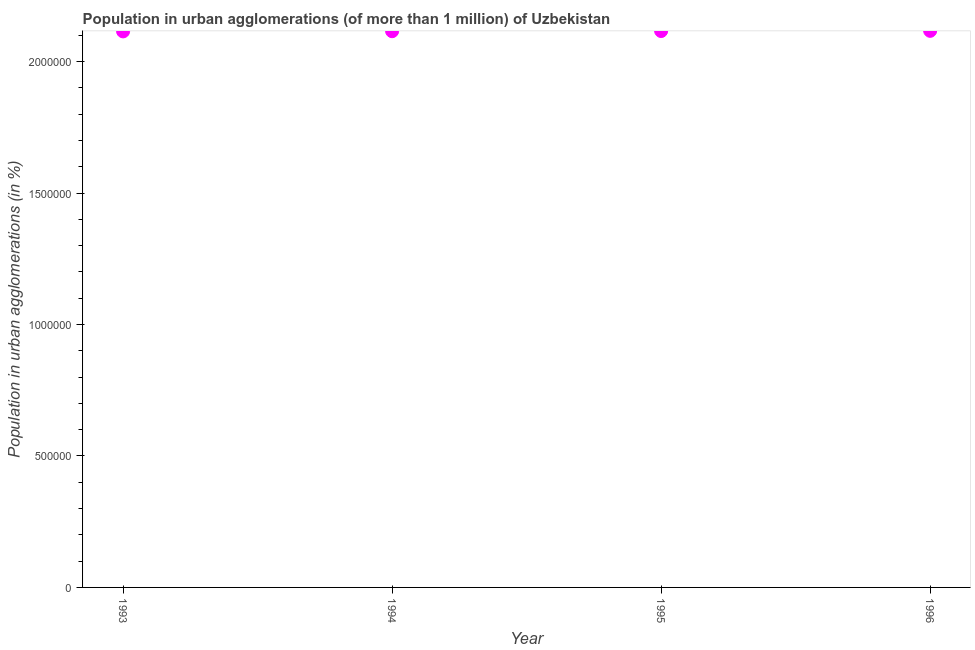What is the population in urban agglomerations in 1994?
Keep it short and to the point. 2.12e+06. Across all years, what is the maximum population in urban agglomerations?
Make the answer very short. 2.12e+06. Across all years, what is the minimum population in urban agglomerations?
Offer a terse response. 2.12e+06. What is the sum of the population in urban agglomerations?
Provide a short and direct response. 8.46e+06. What is the difference between the population in urban agglomerations in 1995 and 1996?
Provide a short and direct response. -702. What is the average population in urban agglomerations per year?
Ensure brevity in your answer.  2.12e+06. What is the median population in urban agglomerations?
Your response must be concise. 2.12e+06. What is the ratio of the population in urban agglomerations in 1994 to that in 1995?
Offer a terse response. 1. Is the population in urban agglomerations in 1993 less than that in 1995?
Provide a short and direct response. Yes. What is the difference between the highest and the second highest population in urban agglomerations?
Offer a very short reply. 702. Is the sum of the population in urban agglomerations in 1993 and 1995 greater than the maximum population in urban agglomerations across all years?
Ensure brevity in your answer.  Yes. What is the difference between the highest and the lowest population in urban agglomerations?
Your response must be concise. 2102. Does the population in urban agglomerations monotonically increase over the years?
Ensure brevity in your answer.  Yes. How many dotlines are there?
Offer a very short reply. 1. Are the values on the major ticks of Y-axis written in scientific E-notation?
Give a very brief answer. No. Does the graph contain any zero values?
Offer a very short reply. No. What is the title of the graph?
Ensure brevity in your answer.  Population in urban agglomerations (of more than 1 million) of Uzbekistan. What is the label or title of the X-axis?
Keep it short and to the point. Year. What is the label or title of the Y-axis?
Provide a short and direct response. Population in urban agglomerations (in %). What is the Population in urban agglomerations (in %) in 1993?
Give a very brief answer. 2.12e+06. What is the Population in urban agglomerations (in %) in 1994?
Give a very brief answer. 2.12e+06. What is the Population in urban agglomerations (in %) in 1995?
Your response must be concise. 2.12e+06. What is the Population in urban agglomerations (in %) in 1996?
Your answer should be very brief. 2.12e+06. What is the difference between the Population in urban agglomerations (in %) in 1993 and 1994?
Your answer should be very brief. -700. What is the difference between the Population in urban agglomerations (in %) in 1993 and 1995?
Ensure brevity in your answer.  -1400. What is the difference between the Population in urban agglomerations (in %) in 1993 and 1996?
Your response must be concise. -2102. What is the difference between the Population in urban agglomerations (in %) in 1994 and 1995?
Offer a very short reply. -700. What is the difference between the Population in urban agglomerations (in %) in 1994 and 1996?
Offer a terse response. -1402. What is the difference between the Population in urban agglomerations (in %) in 1995 and 1996?
Your response must be concise. -702. What is the ratio of the Population in urban agglomerations (in %) in 1993 to that in 1995?
Give a very brief answer. 1. What is the ratio of the Population in urban agglomerations (in %) in 1995 to that in 1996?
Your answer should be compact. 1. 